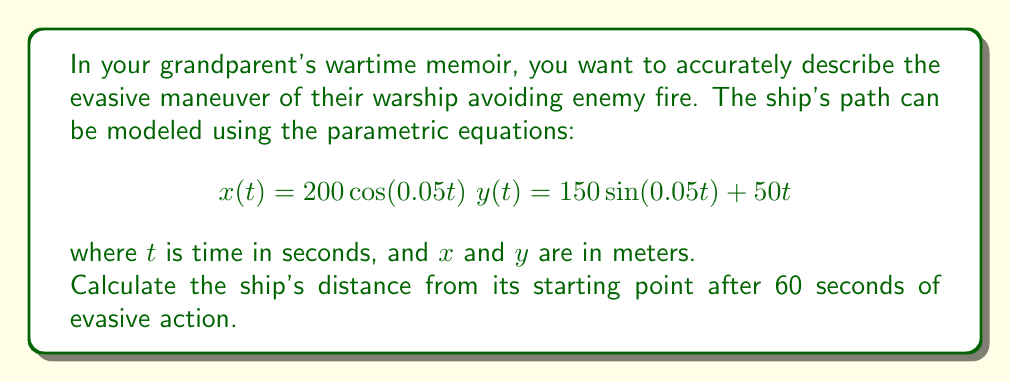Can you solve this math problem? To solve this problem, we need to follow these steps:

1) The ship's position at any time $t$ is given by the point $(x(t), y(t))$.

2) At $t = 0$ (the starting point), the ship's position is:
   $x(0) = 200\cos(0) = 200$
   $y(0) = 150\sin(0) + 50(0) = 0$
   So, the starting point is (200, 0).

3) At $t = 60$ seconds, the ship's position is:
   $x(60) = 200\cos(0.05 * 60) = 200\cos(3) \approx -99.0$
   $y(60) = 150\sin(0.05 * 60) + 50(60) = 150\sin(3) + 3000 \approx 3141.1$

4) To find the distance between two points, we use the distance formula:
   $$d = \sqrt{(x_2-x_1)^2 + (y_2-y_1)^2}$$

5) Plugging in our values:
   $$d = \sqrt{(-99.0-200)^2 + (3141.1-0)^2}$$
   $$d = \sqrt{(-299)^2 + (3141.1)^2}$$
   $$d = \sqrt{89401 + 9866507.21}$$
   $$d = \sqrt{9955908.21}$$
   $$d \approx 3155.0$$

Therefore, after 60 seconds, the ship is approximately 3155.0 meters from its starting point.
Answer: 3155.0 meters 